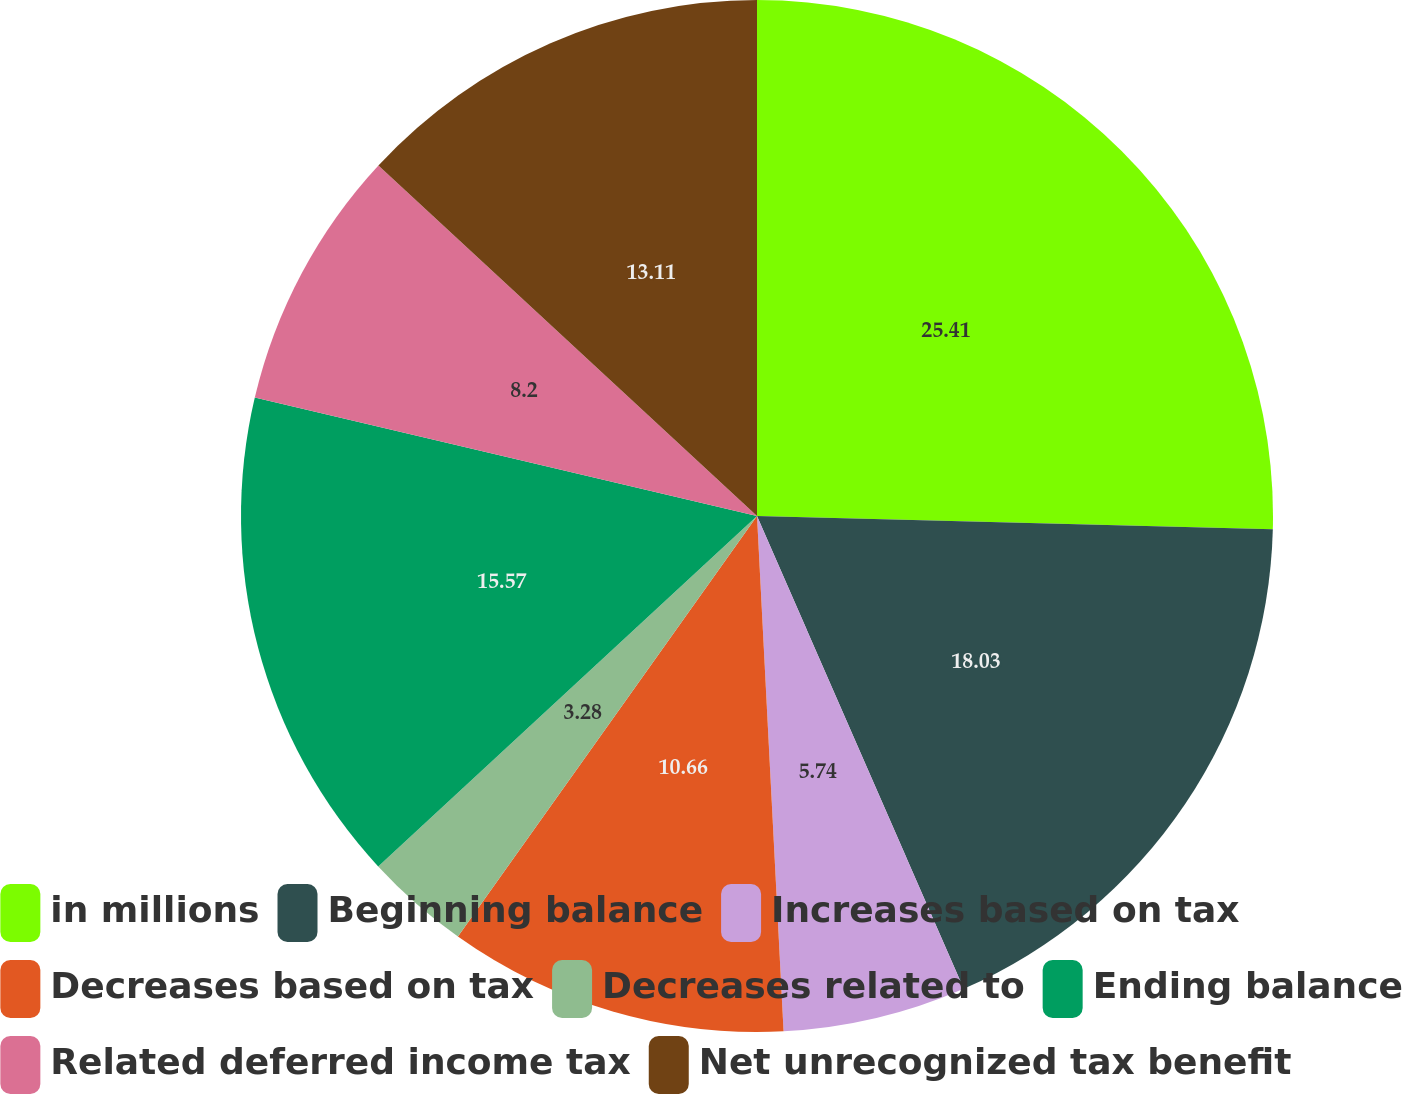Convert chart. <chart><loc_0><loc_0><loc_500><loc_500><pie_chart><fcel>in millions<fcel>Beginning balance<fcel>Increases based on tax<fcel>Decreases based on tax<fcel>Decreases related to<fcel>Ending balance<fcel>Related deferred income tax<fcel>Net unrecognized tax benefit<nl><fcel>25.41%<fcel>18.03%<fcel>5.74%<fcel>10.66%<fcel>3.28%<fcel>15.57%<fcel>8.2%<fcel>13.11%<nl></chart> 